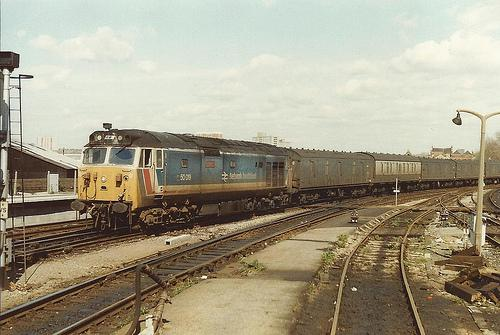Question: what is on the tracks?
Choices:
A. A dog.
B. A boy.
C. A man.
D. A train.
Answer with the letter. Answer: D Question: how many trains are there?
Choices:
A. Three.
B. One.
C. Two.
D. Five.
Answer with the letter. Answer: B Question: what color is the train?
Choices:
A. Yellow.
B. Blue.
C. Red.
D. Green.
Answer with the letter. Answer: B Question: what are the tracks made of?
Choices:
A. Steel.
B. Wood.
C. Metal.
D. Copper.
Answer with the letter. Answer: A Question: why is it so bright?
Choices:
A. Sunny.
B. Because of lights.
C. Because of fire.
D. Because of reflection.
Answer with the letter. Answer: A Question: when was the photo taken?
Choices:
A. Day time.
B. Yesterday.
C. Today.
D. Last year.
Answer with the letter. Answer: A Question: where was the photo taken?
Choices:
A. Train depot.
B. From the road.
C. A bridge.
D. Along railroad tracks.
Answer with the letter. Answer: D 